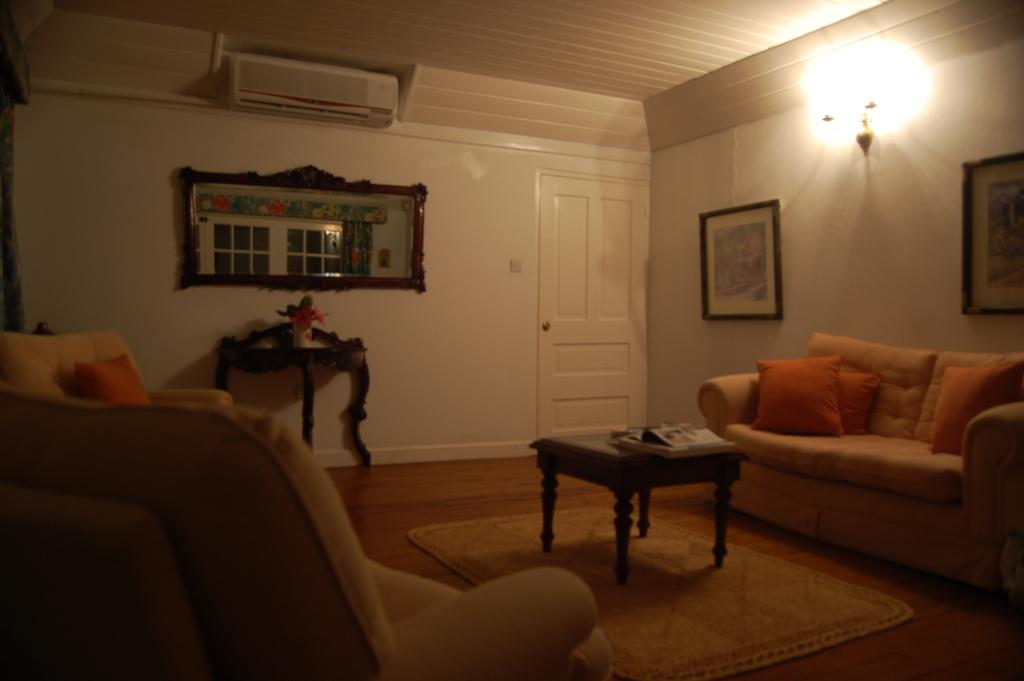How many couches are in the image? There are 2 couches in the image. What can be seen on the couches? There are pillows on the couches. What is visible in the background of the image? There is a wall, a door, a photo frame, an air conditioner, a light, and a mirror in the background of the image. What type of sleet can be seen falling outside the window in the image? There is no window or sleet present in the image. What is the size of the mirror in the image? The size of the mirror cannot be determined from the image alone, as there is no scale provided. 